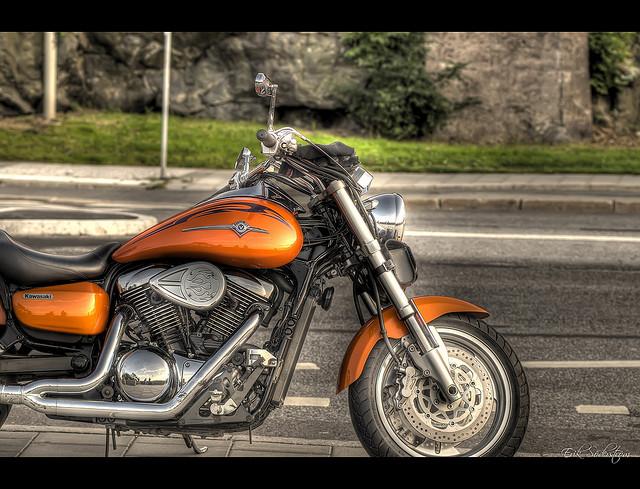What are the marks on the road?
Answer briefly. Lane markers. What color is the bike?
Answer briefly. Orange. Why is only part of the motorcycle visible?
Short answer required. Camera frame ends there. 